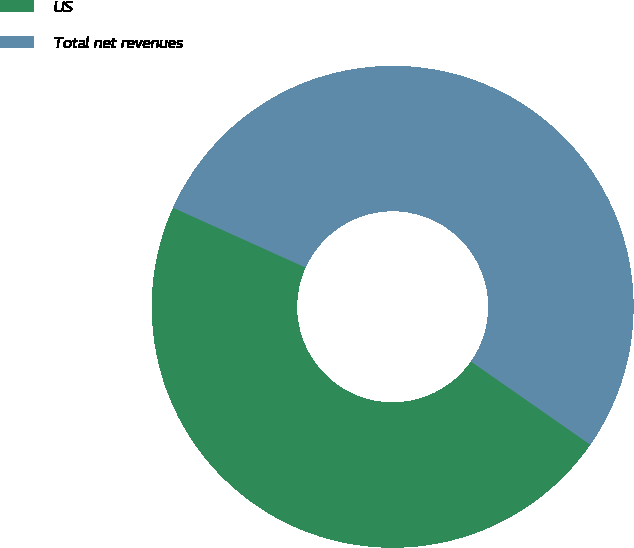<chart> <loc_0><loc_0><loc_500><loc_500><pie_chart><fcel>US<fcel>Total net revenues<nl><fcel>47.06%<fcel>52.94%<nl></chart> 